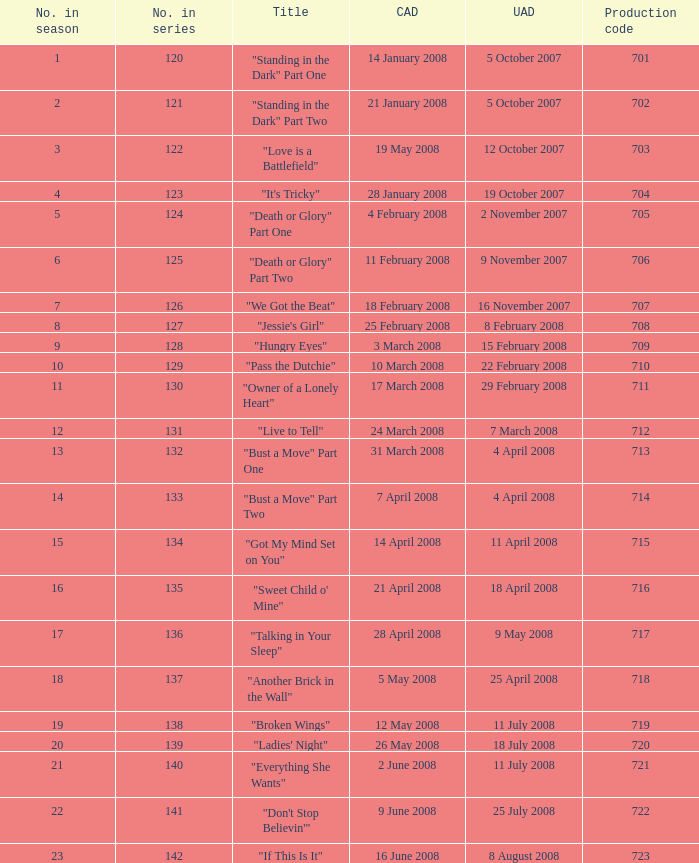Can you parse all the data within this table? {'header': ['No. in season', 'No. in series', 'Title', 'CAD', 'UAD', 'Production code'], 'rows': [['1', '120', '"Standing in the Dark" Part One', '14 January 2008', '5 October 2007', '701'], ['2', '121', '"Standing in the Dark" Part Two', '21 January 2008', '5 October 2007', '702'], ['3', '122', '"Love is a Battlefield"', '19 May 2008', '12 October 2007', '703'], ['4', '123', '"It\'s Tricky"', '28 January 2008', '19 October 2007', '704'], ['5', '124', '"Death or Glory" Part One', '4 February 2008', '2 November 2007', '705'], ['6', '125', '"Death or Glory" Part Two', '11 February 2008', '9 November 2007', '706'], ['7', '126', '"We Got the Beat"', '18 February 2008', '16 November 2007', '707'], ['8', '127', '"Jessie\'s Girl"', '25 February 2008', '8 February 2008', '708'], ['9', '128', '"Hungry Eyes"', '3 March 2008', '15 February 2008', '709'], ['10', '129', '"Pass the Dutchie"', '10 March 2008', '22 February 2008', '710'], ['11', '130', '"Owner of a Lonely Heart"', '17 March 2008', '29 February 2008', '711'], ['12', '131', '"Live to Tell"', '24 March 2008', '7 March 2008', '712'], ['13', '132', '"Bust a Move" Part One', '31 March 2008', '4 April 2008', '713'], ['14', '133', '"Bust a Move" Part Two', '7 April 2008', '4 April 2008', '714'], ['15', '134', '"Got My Mind Set on You"', '14 April 2008', '11 April 2008', '715'], ['16', '135', '"Sweet Child o\' Mine"', '21 April 2008', '18 April 2008', '716'], ['17', '136', '"Talking in Your Sleep"', '28 April 2008', '9 May 2008', '717'], ['18', '137', '"Another Brick in the Wall"', '5 May 2008', '25 April 2008', '718'], ['19', '138', '"Broken Wings"', '12 May 2008', '11 July 2008', '719'], ['20', '139', '"Ladies\' Night"', '26 May 2008', '18 July 2008', '720'], ['21', '140', '"Everything She Wants"', '2 June 2008', '11 July 2008', '721'], ['22', '141', '"Don\'t Stop Believin\'"', '9 June 2008', '25 July 2008', '722'], ['23', '142', '"If This Is It"', '16 June 2008', '8 August 2008', '723']]} The canadian airdate of 17 march 2008 had how many numbers in the season? 1.0. 